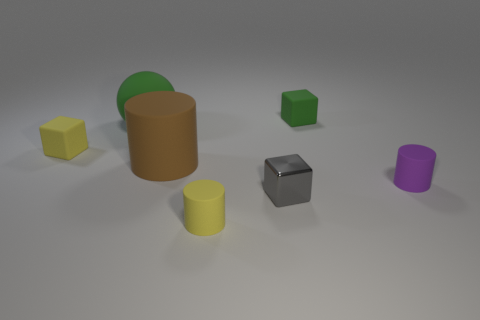Does the brown rubber cylinder have the same size as the green sphere?
Ensure brevity in your answer.  Yes. Are the green block on the right side of the green matte sphere and the gray block made of the same material?
Keep it short and to the point. No. Is there anything else that has the same material as the big sphere?
Your answer should be very brief. Yes. How many small matte blocks are left of the small block that is in front of the rubber block that is on the left side of the yellow cylinder?
Provide a succinct answer. 1. Is the shape of the big matte thing that is right of the large green thing the same as  the small purple rubber object?
Make the answer very short. Yes. What number of objects are big blue cubes or small objects behind the large green rubber thing?
Make the answer very short. 1. Is the number of small gray cubes that are in front of the brown rubber object greater than the number of big gray metal balls?
Your response must be concise. Yes. Are there the same number of small matte objects that are on the left side of the gray shiny block and large brown matte objects right of the green rubber ball?
Ensure brevity in your answer.  No. There is a small purple matte thing that is in front of the large brown rubber cylinder; is there a object that is behind it?
Provide a short and direct response. Yes. What is the shape of the brown matte object?
Make the answer very short. Cylinder. 